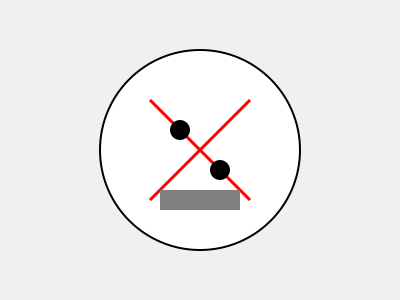Based on the crime scene photograph provided, which piece of evidence should be prioritized for collection and analysis to ensure the integrity of the investigation? 1. Assess the overall scene: The image shows a circular area (likely a room) with several key elements.

2. Identify visible evidence:
   a. Two dark circular objects (possibly bullet holes or blood spatter)
   b. A cross-shaped pattern in red (possibly blood spatter or trajectory lines)
   c. A rectangular object at the bottom (possibly a weapon or tool)

3. Consider the importance of each piece of evidence:
   a. The dark circular objects could be entry points for projectiles or blood evidence.
   b. The cross-shaped pattern might indicate a violent incident or trajectory analysis.
   c. The rectangular object could be a potential murder weapon or tool used in the crime.

4. Evaluate based on protocol:
   a. Trace evidence (like blood) can degrade quickly and should be collected promptly.
   b. The potential weapon is less likely to degrade but is crucial for ballistics or DNA analysis.

5. Prioritize based on potential value and risk of loss:
   The blood evidence (represented by the cross-shaped pattern) is most at risk of degradation and contamination. It can provide crucial DNA evidence and help reconstruct the event.

6. Consider the chain of custody:
   Collecting and properly documenting the blood evidence first ensures its integrity for future analysis and potential court proceedings.
Answer: Blood evidence (cross-shaped pattern) 